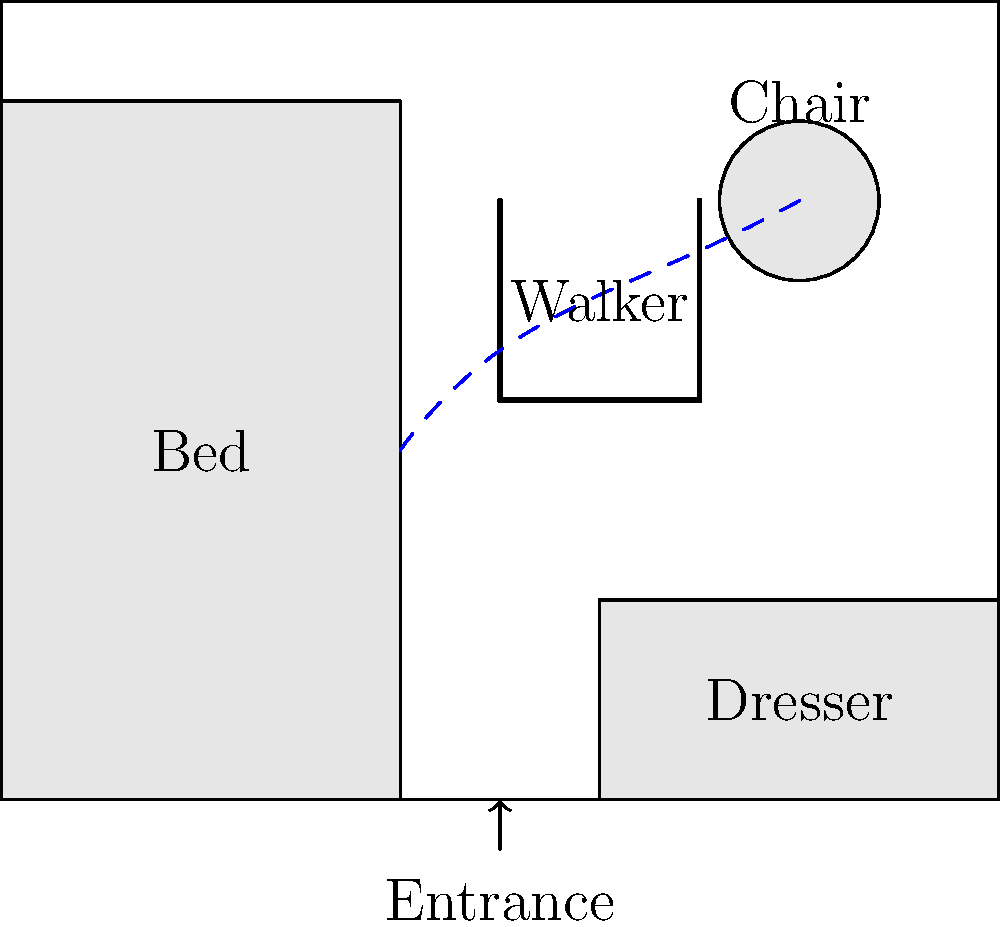In the given room layout for an elderly person, which path would be most suitable for safe mobility when moving from the bed to the chair using a walker? To determine the safest path for the elderly person to move from the bed to the chair using a walker, we need to consider several factors:

1. Space constraints: The room has limited space, with furniture placed along the walls.

2. Walker usage: The elderly person uses a walker, which requires a wider turning radius and more space to maneuver.

3. Obstacle avoidance: We need to minimize the risk of bumping into furniture or walls.

4. Distance: While not the primary concern, a shorter path is generally preferable to reduce fatigue.

5. Straight lines: Whenever possible, straight paths are easier to navigate with a walker than curved ones.

Considering these factors, the safest path would be:

a) Start at the foot of the bed, leaving enough space to position the walker.
b) Move straight towards the center of the room, avoiding the dresser.
c) Make a gradual turn towards the chair, maintaining a safe distance from all furniture.
d) Approach the chair from the front, allowing for easy positioning to sit down.

This path, represented by the blue dashed line in the diagram, provides:
- Sufficient space for maneuvering the walker
- A clear path without obstacles
- Gradual turns instead of sharp corners
- A relatively short distance while prioritizing safety
Answer: The curved path from the foot of the bed to the chair, passing through the center of the room (shown by the blue dashed line). 